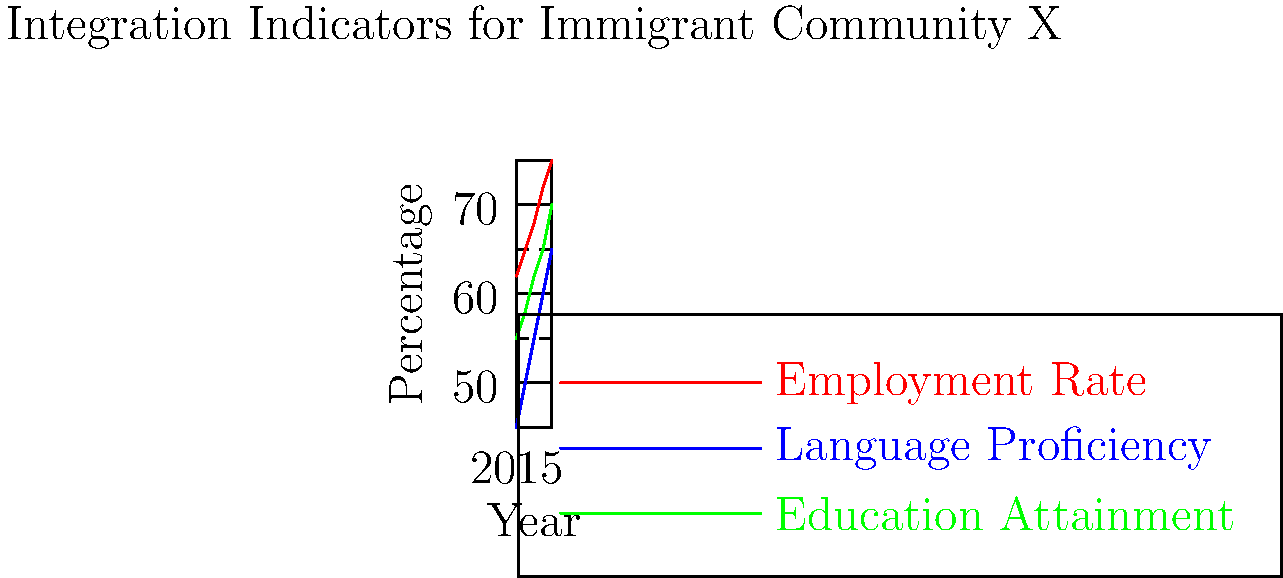Based on the infographic showing integration indicators for Immigrant Community X from 2015 to 2019, which area has shown the most significant improvement, and what policy implication does this suggest for future immigration strategies? To answer this question, we need to analyze the trends for each indicator:

1. Employment Rate:
   - 2015: 62% → 2019: 75%
   - Increase: 13 percentage points

2. Language Proficiency:
   - 2015: 45% → 2019: 65%
   - Increase: 20 percentage points

3. Education Attainment:
   - 2015: 55% → 2019: 70%
   - Increase: 15 percentage points

Language Proficiency shows the most significant improvement with a 20 percentage point increase.

Policy Implication:
The substantial improvement in language proficiency suggests that existing language programs have been effective. Future immigration strategies should:

1. Continue to invest in and expand language training programs.
2. Use this success as a model for improving other areas of integration.
3. Consider linking language proficiency more closely with employment opportunities and education programs to create a synergistic effect on overall integration.
Answer: Language Proficiency; Expand language programs and link them to employment and education initiatives. 